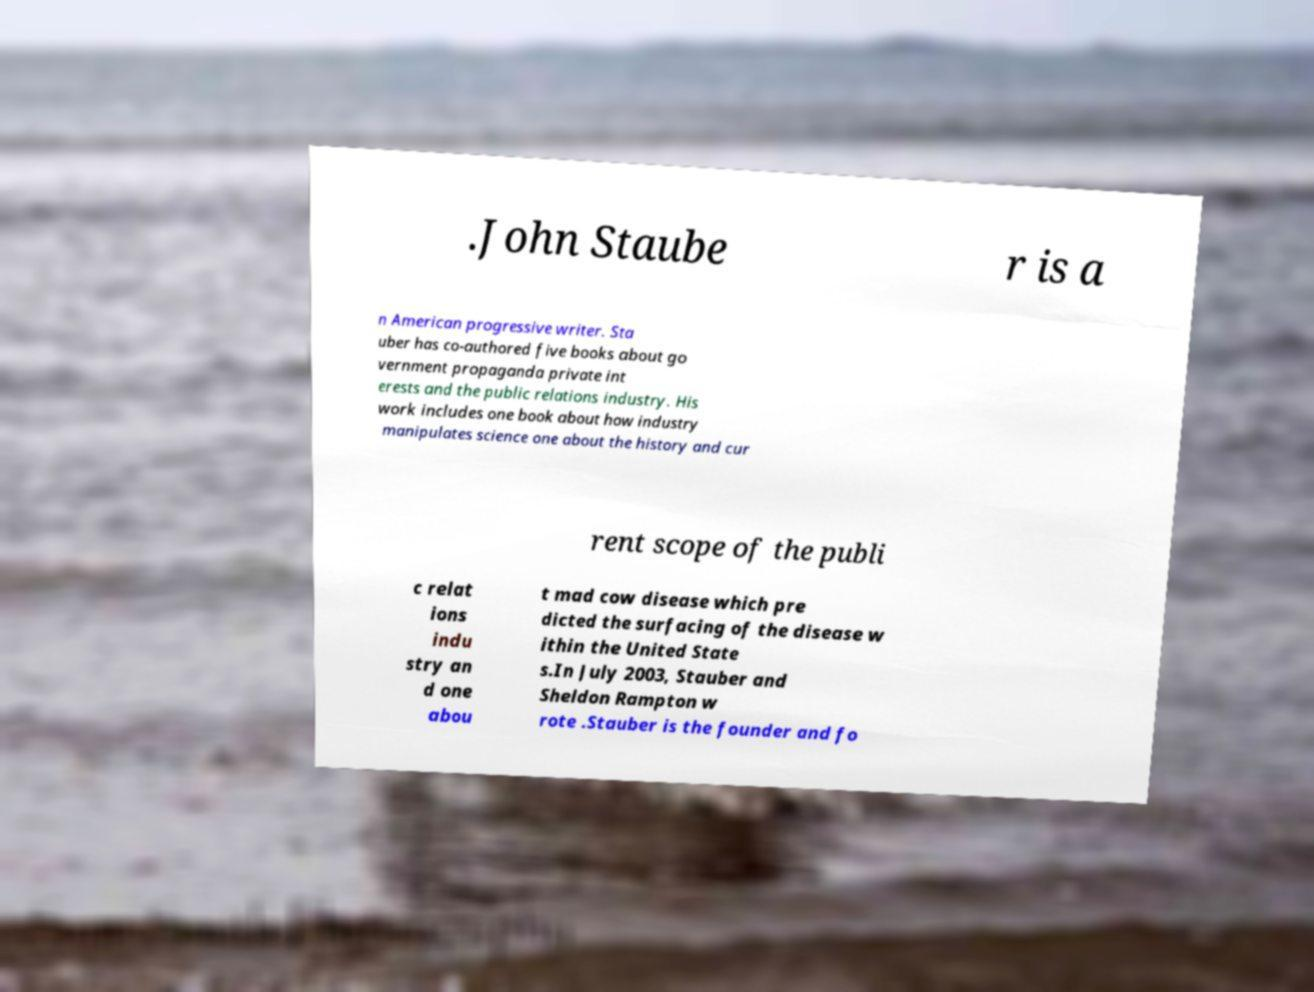Can you accurately transcribe the text from the provided image for me? .John Staube r is a n American progressive writer. Sta uber has co-authored five books about go vernment propaganda private int erests and the public relations industry. His work includes one book about how industry manipulates science one about the history and cur rent scope of the publi c relat ions indu stry an d one abou t mad cow disease which pre dicted the surfacing of the disease w ithin the United State s.In July 2003, Stauber and Sheldon Rampton w rote .Stauber is the founder and fo 